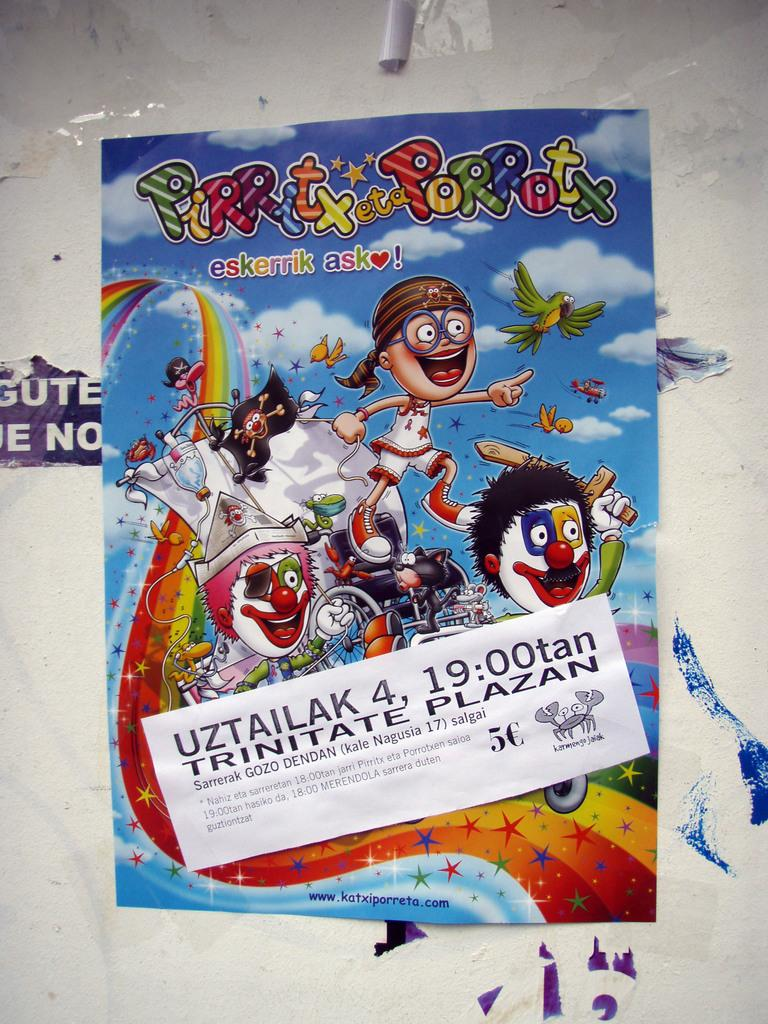<image>
Create a compact narrative representing the image presented. A poster is advertising an event that is taking place at 19:00tan. 